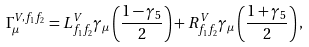<formula> <loc_0><loc_0><loc_500><loc_500>\Gamma _ { \mu } ^ { V , f _ { 1 } f _ { 2 } } = L ^ { V } _ { f _ { 1 } f _ { 2 } } \gamma _ { \mu } \left ( \frac { 1 - \gamma _ { 5 } } { 2 } \right ) + R ^ { V } _ { f _ { 1 } f _ { 2 } } \gamma _ { \mu } \left ( \frac { 1 + \gamma _ { 5 } } { 2 } \right ) ,</formula> 